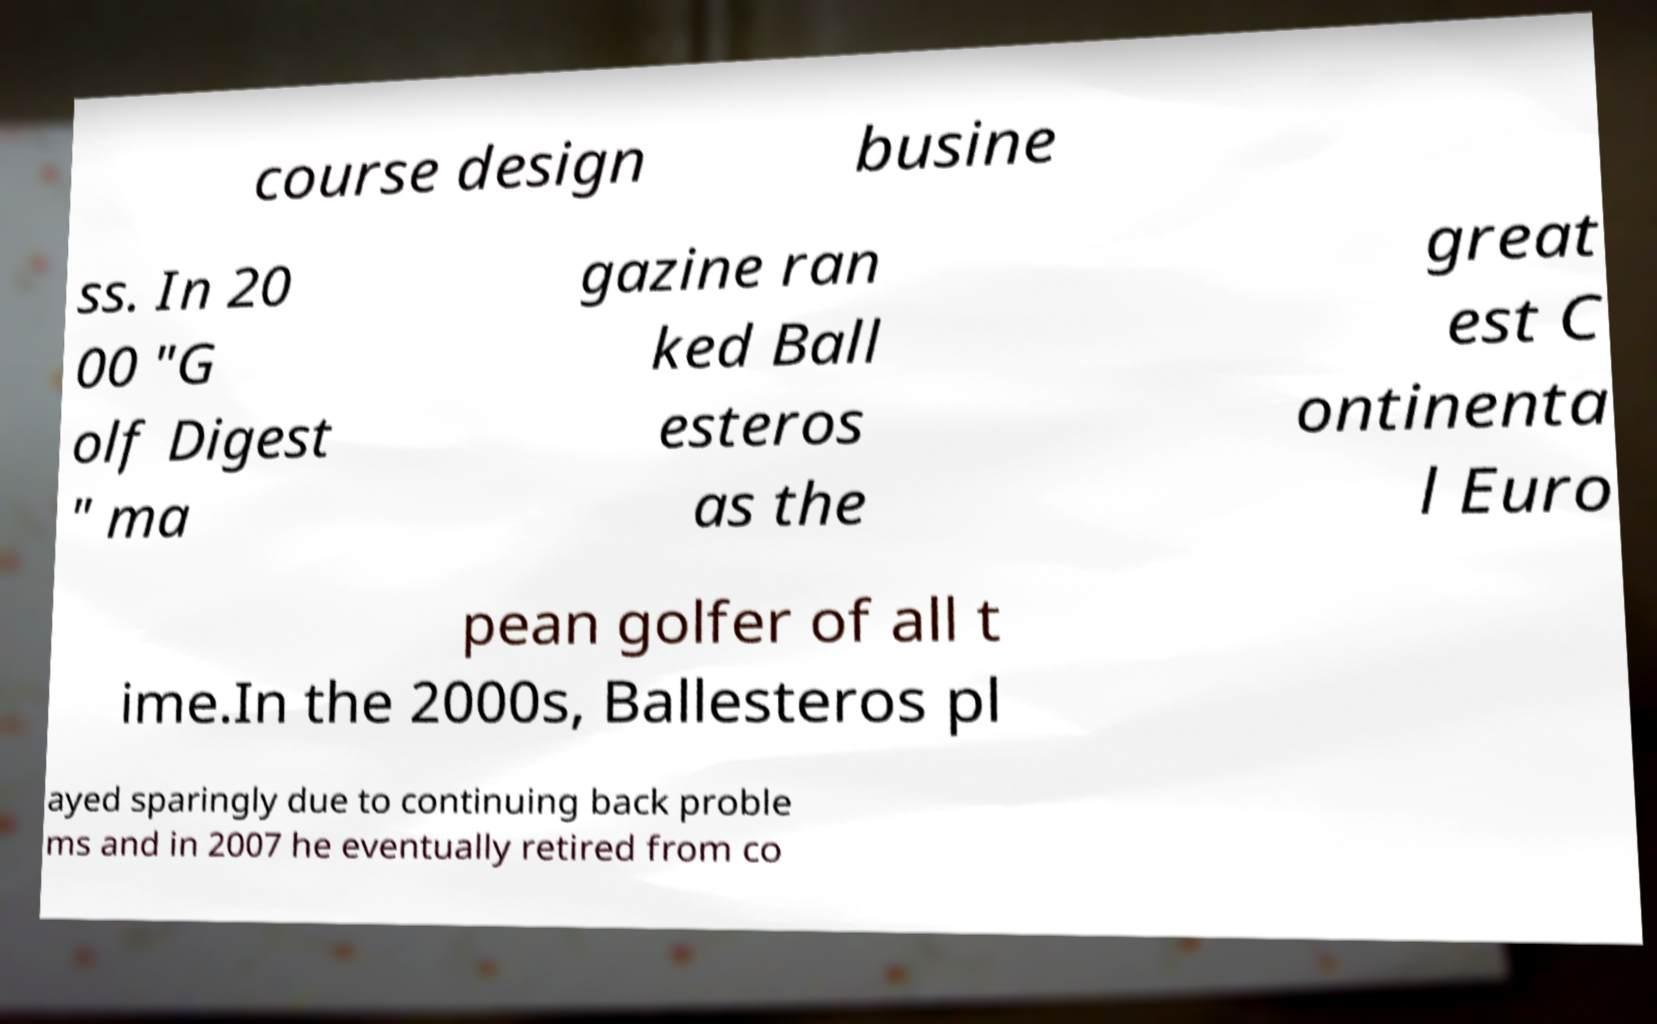Can you read and provide the text displayed in the image?This photo seems to have some interesting text. Can you extract and type it out for me? course design busine ss. In 20 00 "G olf Digest " ma gazine ran ked Ball esteros as the great est C ontinenta l Euro pean golfer of all t ime.In the 2000s, Ballesteros pl ayed sparingly due to continuing back proble ms and in 2007 he eventually retired from co 